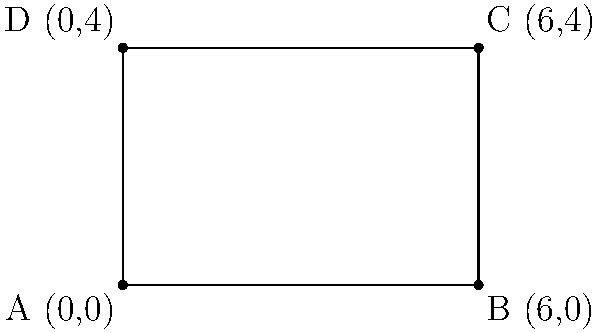Your rival company has just acquired a rectangular plot of land for their new office building. The coordinates of the vertices of this plot are A(0,0), B(6,0), C(6,4), and D(0,4). Calculate the area of this plot to determine if it's larger than your own company's land. To calculate the area of the rectangular plot, we need to follow these steps:

1) In a rectangle, the area is given by the formula: $A = l \times w$, where $l$ is the length and $w$ is the width.

2) To find the length, we can calculate the distance between points A and B:
   $l = |x_B - x_A| = |6 - 0| = 6$ units

3) To find the width, we can calculate the distance between points A and D:
   $w = |y_D - y_A| = |4 - 0| = 4$ units

4) Now we can calculate the area:
   $A = l \times w = 6 \times 4 = 24$ square units

Therefore, the area of the rectangular plot is 24 square units.
Answer: 24 square units 